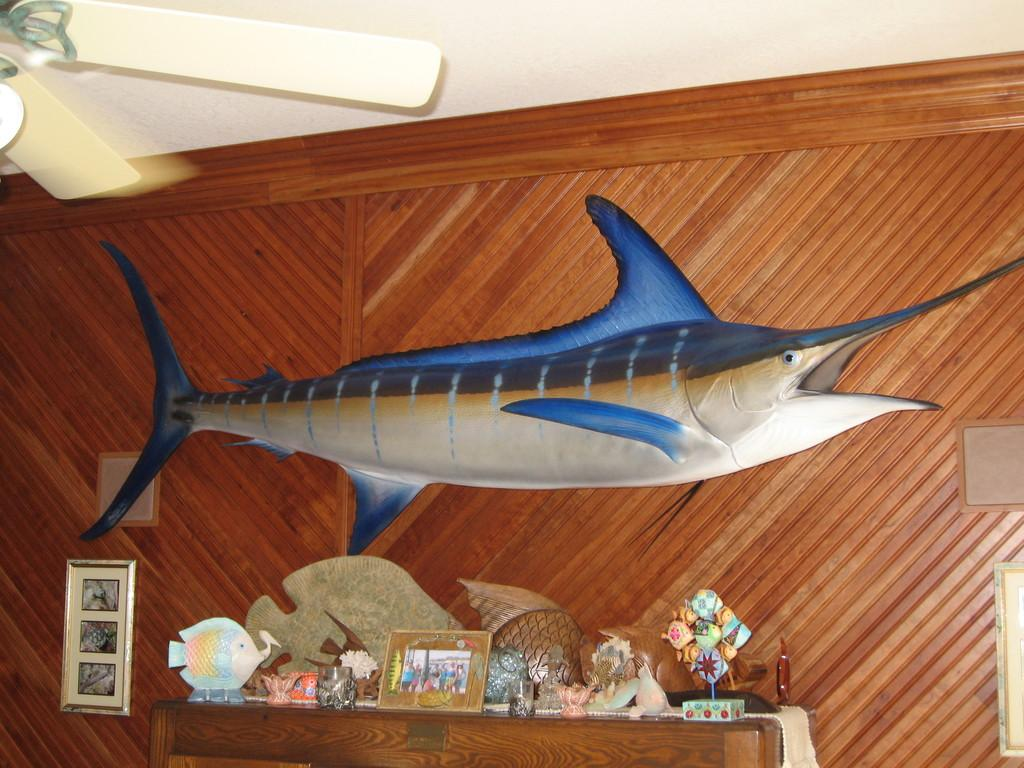What animal is present in the image? There is a shark in the image. What object can be seen at the top of the image? There is a fan visible at the top of the image. What piece of furniture is present in the image? There is a table with objects on it in the image. What can be seen on the wall in the background of the image? There is a wall with photo frames and boards in the background of the image. What invention is being demonstrated by the shark in the image? There is no invention being demonstrated by the shark in the image; it is simply a shark in the scene. What type of curtain can be seen hanging from the wall in the image? There is no curtain present in the image; only a wall with photo frames and boards is visible. 